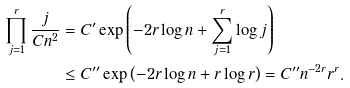Convert formula to latex. <formula><loc_0><loc_0><loc_500><loc_500>\prod _ { j = 1 } ^ { r } \frac { j } { C n ^ { 2 } } & = C ^ { \prime } \exp \left ( - 2 r \log n + \sum _ { j = 1 } ^ { r } \log j \right ) \\ & \leq C ^ { \prime \prime } \exp \left ( - 2 r \log n + r \log r \right ) = C ^ { \prime \prime } n ^ { - 2 r } r ^ { r } .</formula> 